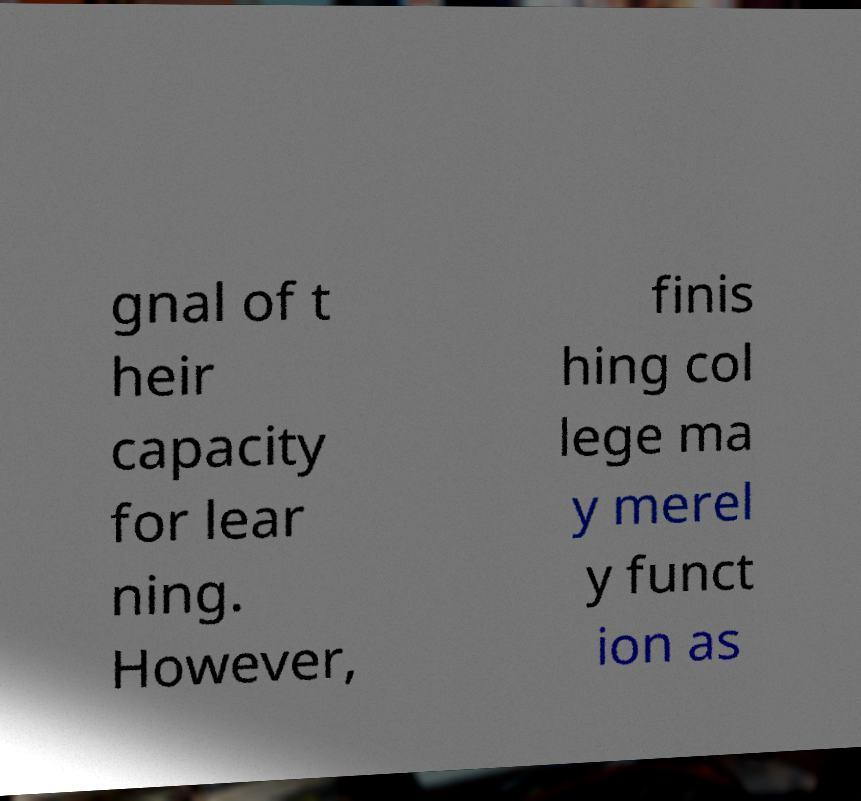What messages or text are displayed in this image? I need them in a readable, typed format. gnal of t heir capacity for lear ning. However, finis hing col lege ma y merel y funct ion as 